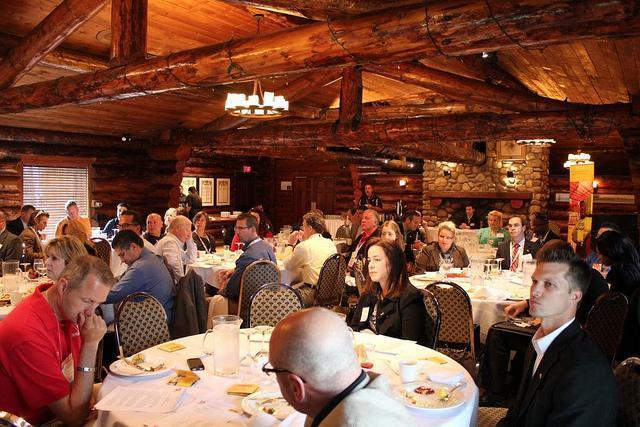How many people are in the photo?
Give a very brief answer. 7. How many chairs are in the picture?
Give a very brief answer. 2. How many dining tables are visible?
Give a very brief answer. 2. 